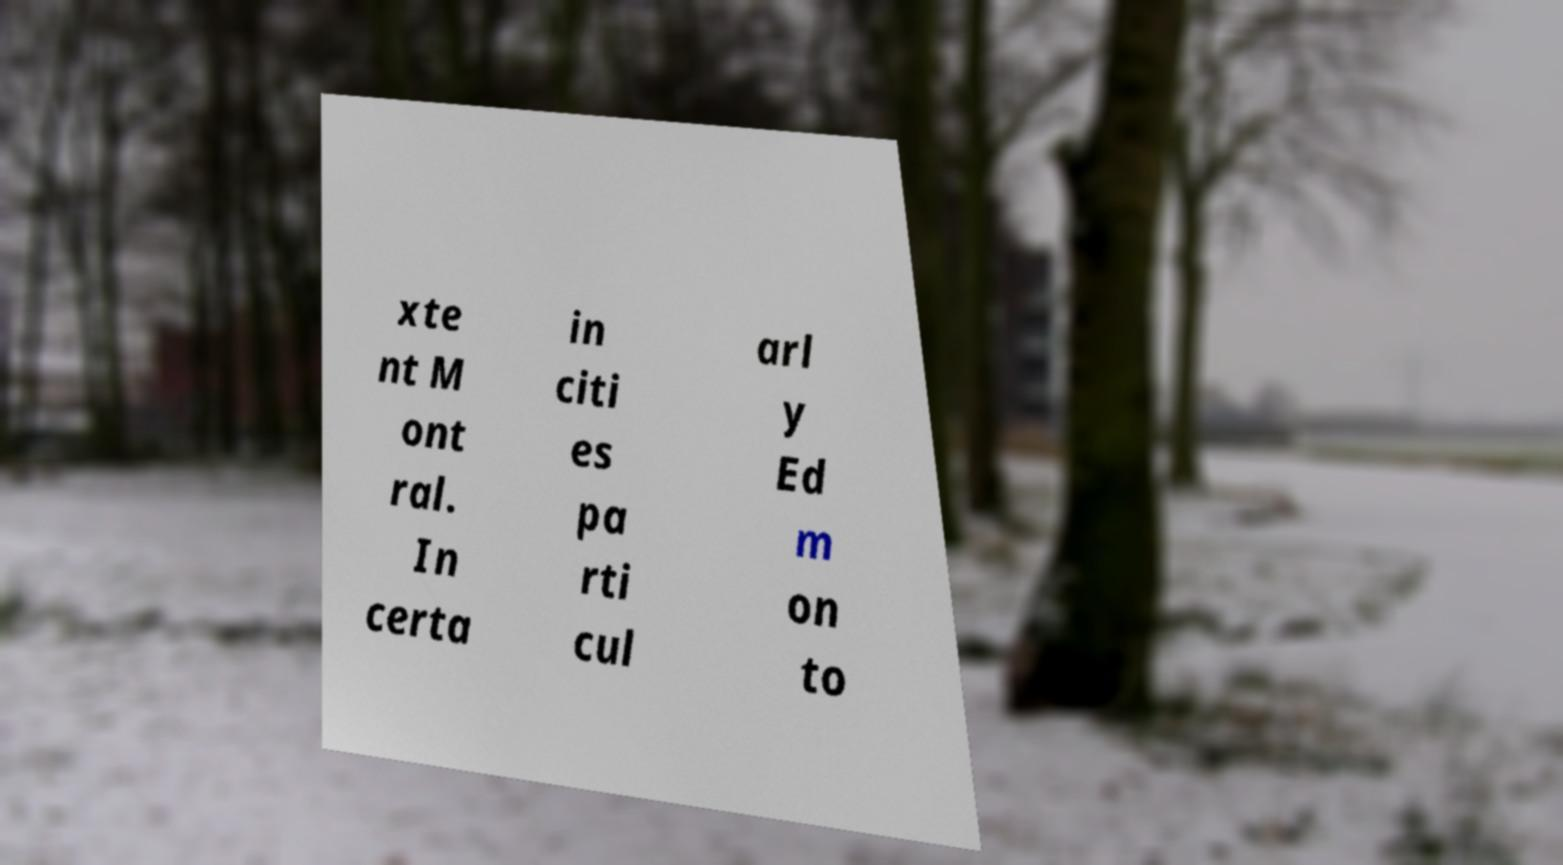Can you accurately transcribe the text from the provided image for me? xte nt M ont ral. In certa in citi es pa rti cul arl y Ed m on to 